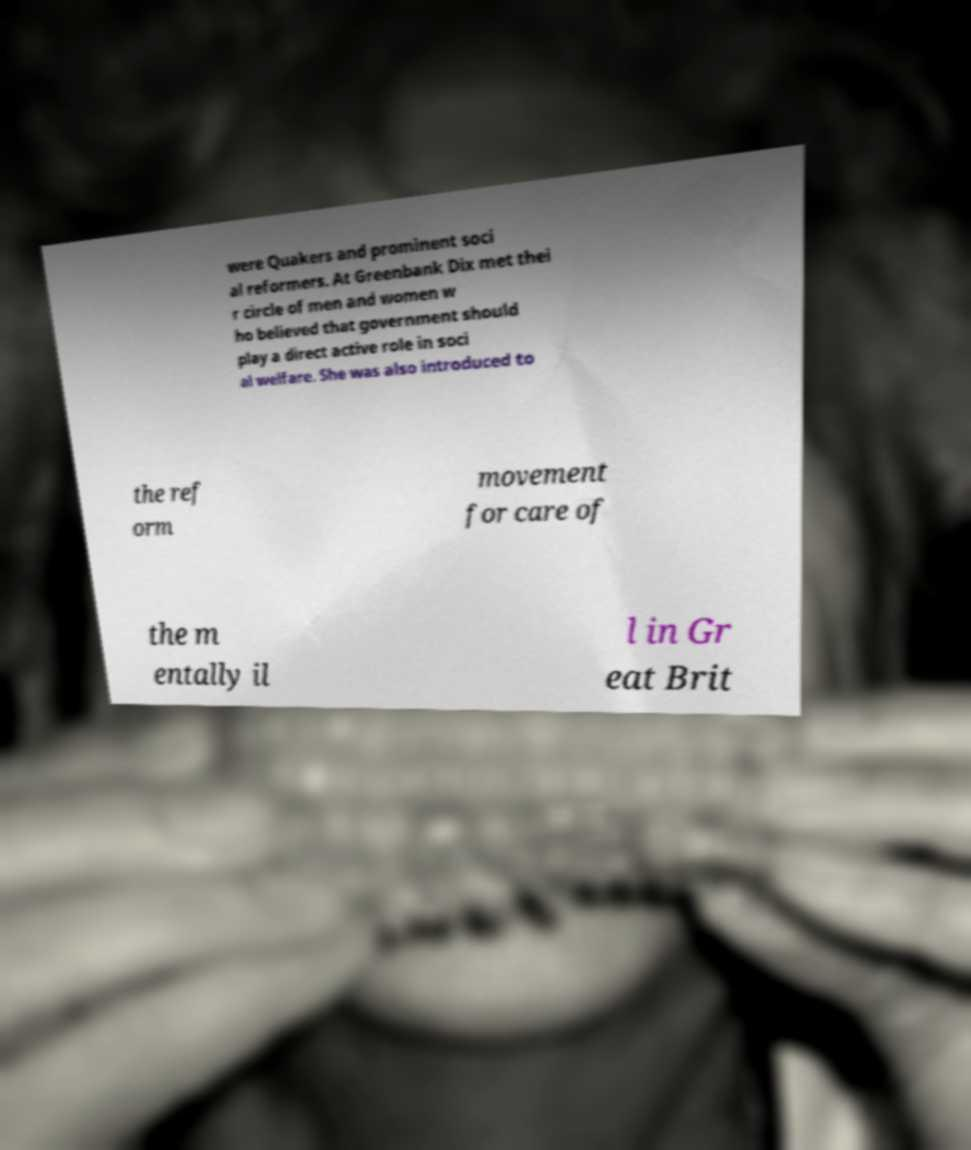Could you assist in decoding the text presented in this image and type it out clearly? were Quakers and prominent soci al reformers. At Greenbank Dix met thei r circle of men and women w ho believed that government should play a direct active role in soci al welfare. She was also introduced to the ref orm movement for care of the m entally il l in Gr eat Brit 